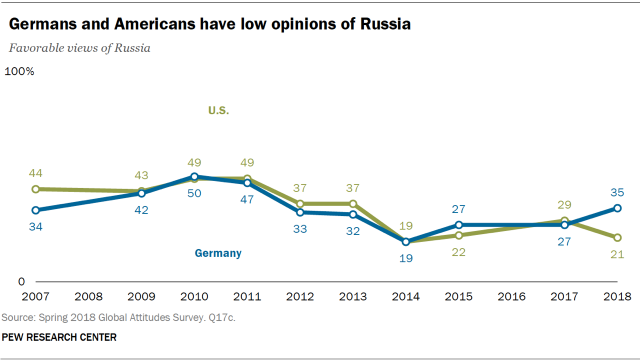Give some essential details in this illustration. The value of blue graph in 2014 was 19. In 2014, the values of blue and green graphs were equal. 